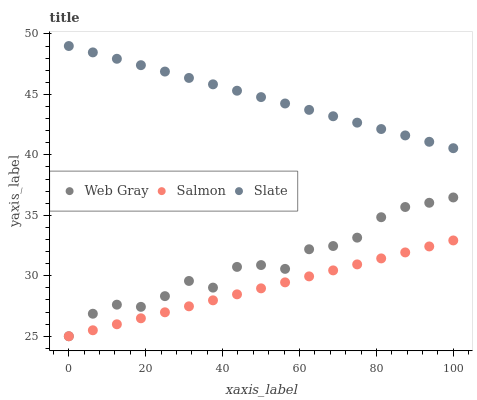Does Salmon have the minimum area under the curve?
Answer yes or no. Yes. Does Slate have the maximum area under the curve?
Answer yes or no. Yes. Does Web Gray have the minimum area under the curve?
Answer yes or no. No. Does Web Gray have the maximum area under the curve?
Answer yes or no. No. Is Salmon the smoothest?
Answer yes or no. Yes. Is Web Gray the roughest?
Answer yes or no. Yes. Is Web Gray the smoothest?
Answer yes or no. No. Is Salmon the roughest?
Answer yes or no. No. Does Web Gray have the lowest value?
Answer yes or no. Yes. Does Slate have the highest value?
Answer yes or no. Yes. Does Web Gray have the highest value?
Answer yes or no. No. Is Web Gray less than Slate?
Answer yes or no. Yes. Is Slate greater than Salmon?
Answer yes or no. Yes. Does Web Gray intersect Salmon?
Answer yes or no. Yes. Is Web Gray less than Salmon?
Answer yes or no. No. Is Web Gray greater than Salmon?
Answer yes or no. No. Does Web Gray intersect Slate?
Answer yes or no. No. 